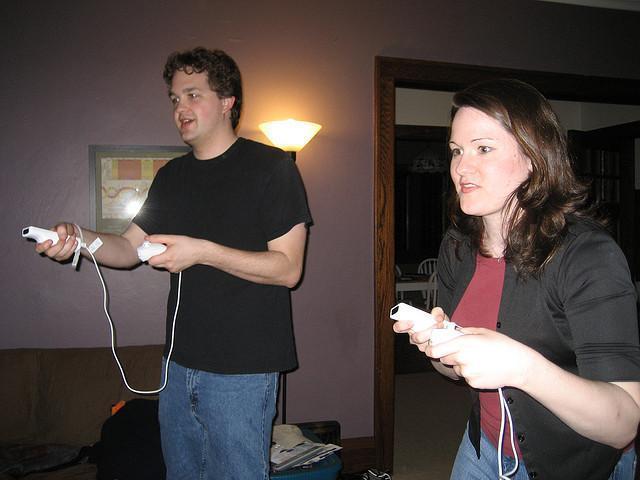How many people can be seen?
Give a very brief answer. 2. 